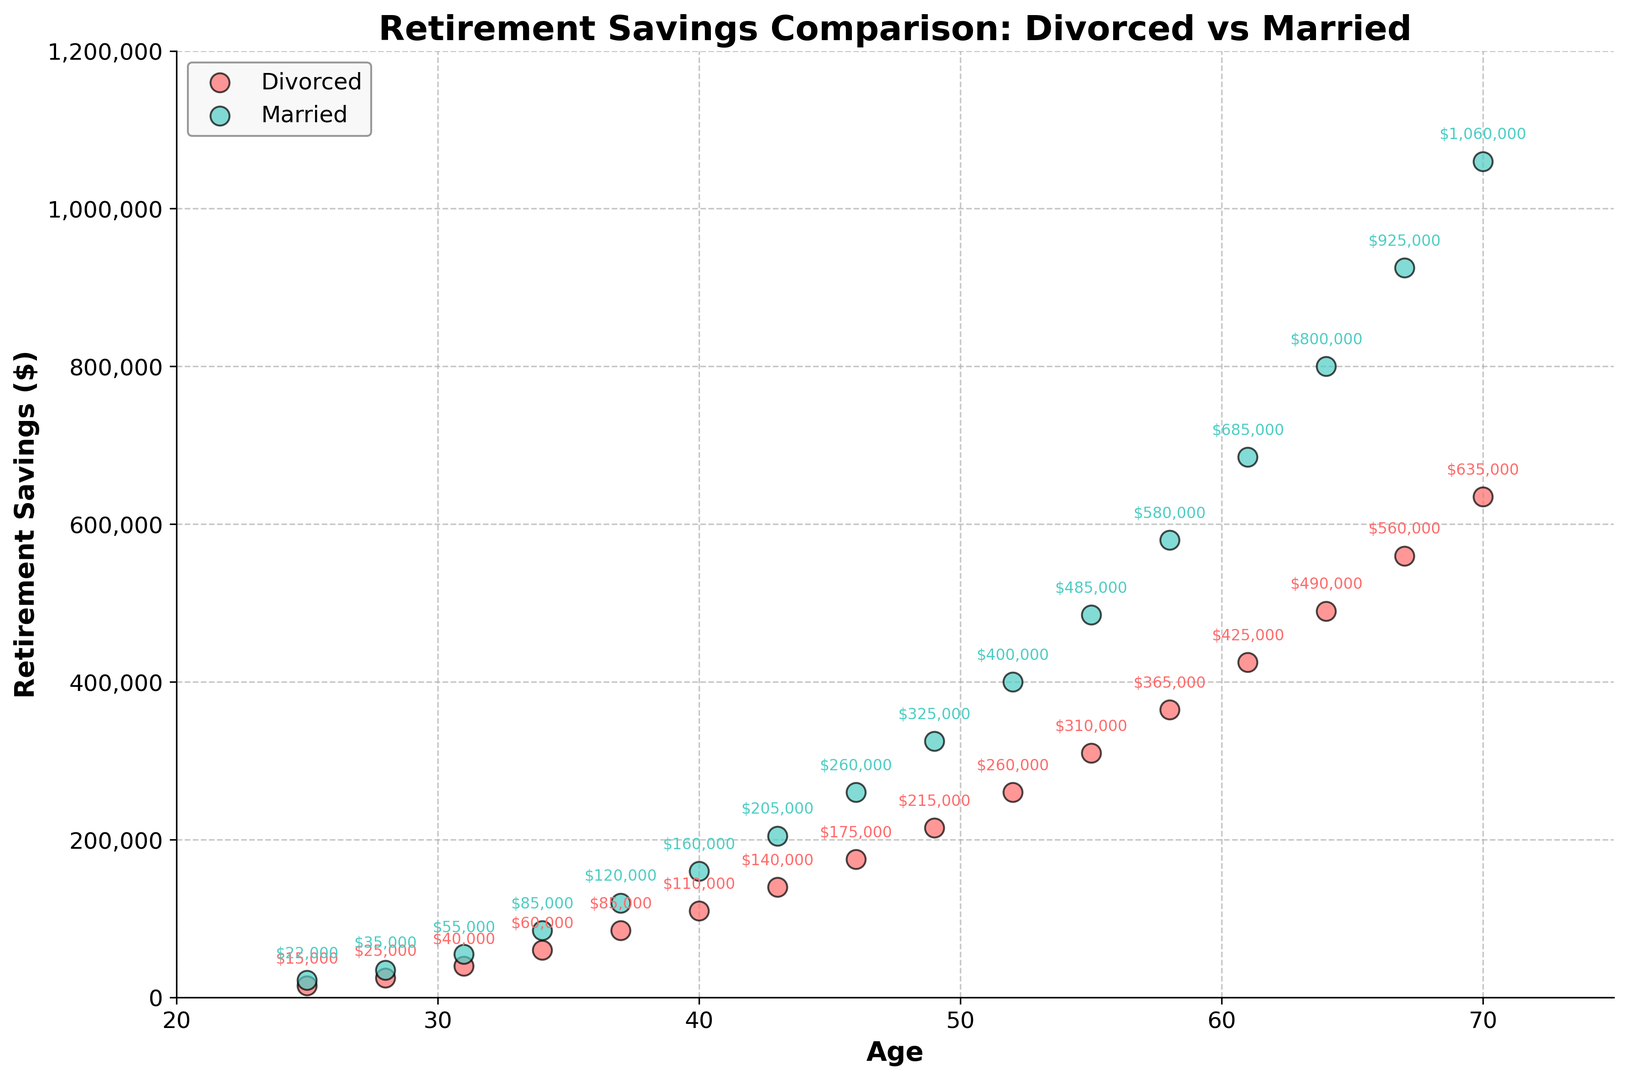What is the difference in retirement savings between divorced and married individuals at age 40? At age 40, the plot shows divorced individuals have $110,000 in retirement savings while married individuals have $160,000. The difference can be calculated as $160,000 - $110,000.
Answer: $50,000 How does the retirement savings trajectory of divorced individuals compare to that of married individuals as they age from 25 to 70? By observing the plots, retirement savings for both groups increase with age. However, married individuals generally have higher retirement savings across all ages depicted.
Answer: Married individuals generally have higher savings At what age do married individuals first exceed $500,000 in retirement savings? Observing the scatter plot reveals married individuals surpass $500,000 in retirement savings between the ages of 58 and 61. Checking data points at ages 61 shows $685,000 in retirement savings, confirming the surplus.
Answer: Age 61 Is there an age where divorced individuals have higher retirement savings than married individuals? By examining all the data points on the scatter plot, it is clear that married individuals consistently have higher retirement savings across all age groups shown.
Answer: No Between the ages of 46 and 55, by how much do retirement savings for married individuals exceed those for divorced individuals on average? At age 46, the difference is $260,000 - $175,000 = $85,000. At age 49, it is $325,000 - $215,000 = $110,000. At age 52, it is $400,000 - $260,000 = $140,000. At age 55, it is $485,000 - $310,000 = $175,000. Average = ($85,000 + $110,000 + $140,000 + $175,000) / 4.
Answer: $127,500 What is the total retirement savings of divorced and married individuals at age 31? At age 31, divorced individuals have $40,000 and married individuals have $55,000 in retirement savings, making the total $40,000 + $55,000.
Answer: $95,000 Which group, divorced or married individuals, shows a steeper increase in retirement savings as they age from 34 to 40? From age 34 to 40, divorced individuals' savings increase from $60,000 to $110,000 (an increase of $50,000), while married individuals' savings rise from $85,000 to $160,000 (an increase of $75,000). Thus, married individuals exhibit a steeper increase.
Answer: Married individuals By what percentage do married individuals' retirement savings at age 43 exceed those of divorced individuals at the same age? At age 43, married individuals have $205,000 and divorced individuals have $140,000. The difference is $205,000 - $140,000 = $65,000. The percentage excess is ($65,000 / $140,000) * 100.
Answer: ~46.4% What is the average retirement savings of divorced individuals at ages 55, 58, and 61? At ages 55, 58, and 61, divorced individuals have $310,000, $365,000, and $425,000 respectively. The average is ($310,000 + $365,000 + $425,000) / 3.
Answer: $366,667 